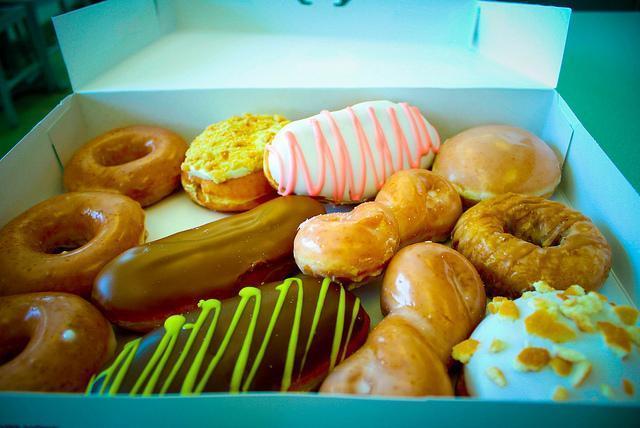How many donuts are there?
Give a very brief answer. 11. 